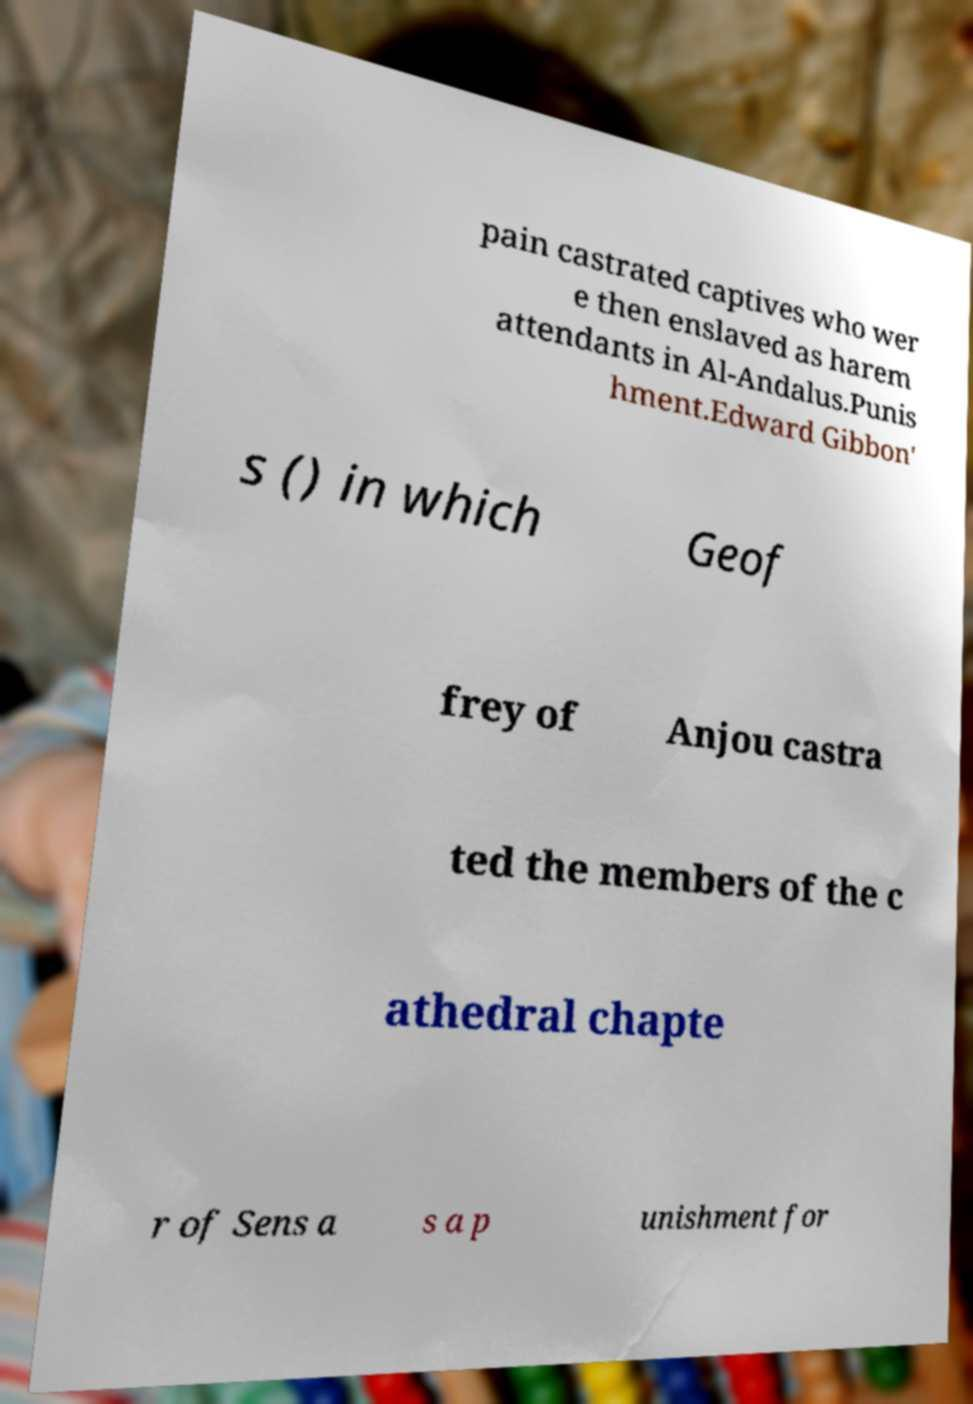Please read and relay the text visible in this image. What does it say? pain castrated captives who wer e then enslaved as harem attendants in Al-Andalus.Punis hment.Edward Gibbon' s () in which Geof frey of Anjou castra ted the members of the c athedral chapte r of Sens a s a p unishment for 